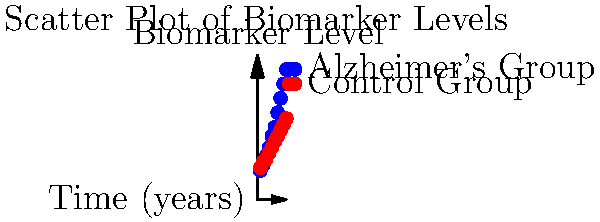Based on the scatter plot showing biomarker levels over time for Alzheimer's and control groups, which of the following statements is most accurate regarding the potential of this biomarker for early detection of Alzheimer's disease? To analyze the potential of this biomarker for early detection of Alzheimer's disease, we need to examine the scatter plot carefully:

1. Observe the two distinct groups: The blue points represent the Alzheimer's group, while the red points represent the control group.

2. Analyze the trend over time:
   - The Alzheimer's group (blue) shows a steeper increase in biomarker levels over time.
   - The control group (red) shows a more gradual increase in biomarker levels.

3. Compare the separation between groups:
   - At earlier time points (years 1-3), there is minimal separation between the two groups.
   - As time progresses, the separation between the groups becomes more pronounced.

4. Evaluate the potential for early detection:
   - The lack of clear separation in the early years suggests that this biomarker may not be ideal for very early detection.
   - However, the increasing separation over time indicates that the biomarker becomes more reliable for distinguishing between Alzheimer's and control groups as the disease progresses.

5. Consider the implications:
   - While not perfect for the earliest stages, this biomarker shows promise for detecting Alzheimer's disease before it reaches advanced stages.
   - The increasing divergence between groups suggests that regular monitoring of this biomarker could help identify the onset of Alzheimer's disease.

Based on these observations, we can conclude that this biomarker shows potential for detecting Alzheimer's disease, but its effectiveness increases over time rather than being optimal for the earliest stages of the disease.
Answer: Moderate potential; effectiveness increases over time 